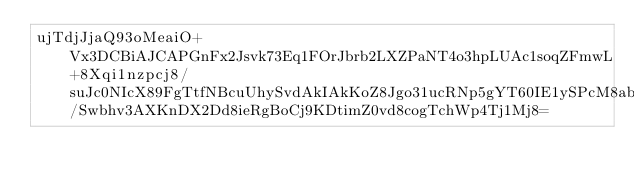Convert code to text. <code><loc_0><loc_0><loc_500><loc_500><_SML_>ujTdjJjaQ93oMeaiO+Vx3DCBiAJCAPGnFx2Jsvk73Eq1FOrJbrb2LXZPaNT4o3hpLUAc1soqZFmwL+8Xqi1nzpcj8/suJc0NIcX89FgTtfNBcuUhySvdAkIAkKoZ8Jgo31ucRNp5gYT60IE1ySPcM8abuKqw/Swbhv3AXKnDX2Dd8ieRgBoCj9KDtimZ0vd8cogTchWp4Tj1Mj8=</code> 